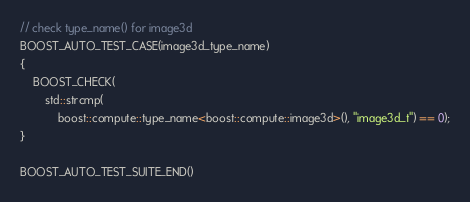Convert code to text. <code><loc_0><loc_0><loc_500><loc_500><_C++_>
// check type_name() for image3d
BOOST_AUTO_TEST_CASE(image3d_type_name)
{
    BOOST_CHECK(
        std::strcmp(
            boost::compute::type_name<boost::compute::image3d>(), "image3d_t") == 0);
}

BOOST_AUTO_TEST_SUITE_END()
</code> 